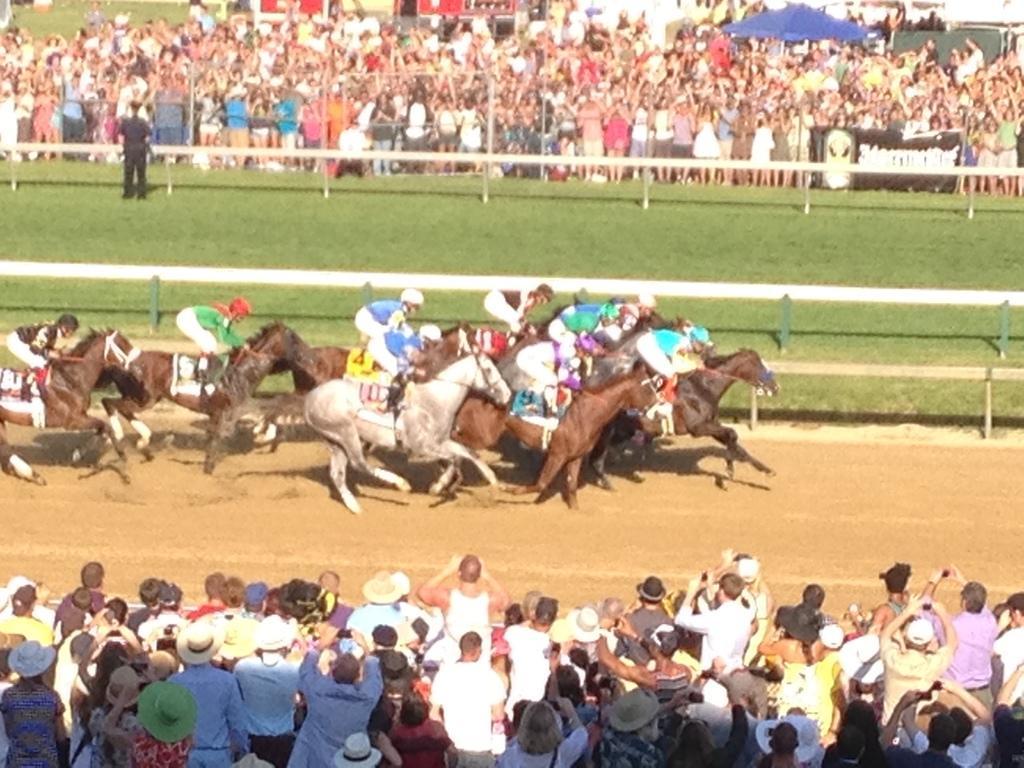Please provide a concise description of this image. In the center of the image there are people riding horses. At the bottom of the image there are people standing. In the background of the image there is a fencing. There is grass. There are people standing. 